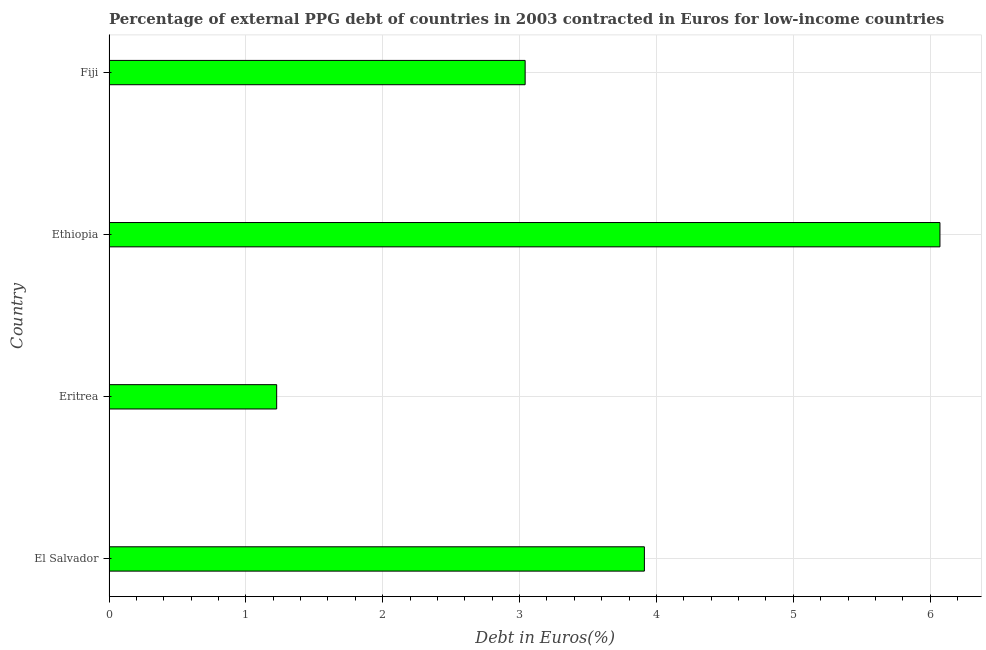Does the graph contain grids?
Your answer should be compact. Yes. What is the title of the graph?
Give a very brief answer. Percentage of external PPG debt of countries in 2003 contracted in Euros for low-income countries. What is the label or title of the X-axis?
Give a very brief answer. Debt in Euros(%). What is the label or title of the Y-axis?
Make the answer very short. Country. What is the currency composition of ppg debt in Fiji?
Offer a very short reply. 3.04. Across all countries, what is the maximum currency composition of ppg debt?
Your answer should be very brief. 6.07. Across all countries, what is the minimum currency composition of ppg debt?
Your answer should be compact. 1.23. In which country was the currency composition of ppg debt maximum?
Your answer should be very brief. Ethiopia. In which country was the currency composition of ppg debt minimum?
Your answer should be very brief. Eritrea. What is the sum of the currency composition of ppg debt?
Ensure brevity in your answer.  14.25. What is the difference between the currency composition of ppg debt in Ethiopia and Fiji?
Your answer should be very brief. 3.03. What is the average currency composition of ppg debt per country?
Offer a very short reply. 3.56. What is the median currency composition of ppg debt?
Provide a short and direct response. 3.48. In how many countries, is the currency composition of ppg debt greater than 4.4 %?
Offer a very short reply. 1. What is the ratio of the currency composition of ppg debt in El Salvador to that in Ethiopia?
Provide a succinct answer. 0.64. Is the difference between the currency composition of ppg debt in El Salvador and Fiji greater than the difference between any two countries?
Provide a succinct answer. No. What is the difference between the highest and the second highest currency composition of ppg debt?
Provide a succinct answer. 2.16. What is the difference between the highest and the lowest currency composition of ppg debt?
Provide a short and direct response. 4.85. In how many countries, is the currency composition of ppg debt greater than the average currency composition of ppg debt taken over all countries?
Ensure brevity in your answer.  2. How many bars are there?
Provide a short and direct response. 4. Are all the bars in the graph horizontal?
Offer a terse response. Yes. What is the difference between two consecutive major ticks on the X-axis?
Your answer should be compact. 1. Are the values on the major ticks of X-axis written in scientific E-notation?
Your answer should be very brief. No. What is the Debt in Euros(%) in El Salvador?
Provide a succinct answer. 3.91. What is the Debt in Euros(%) in Eritrea?
Provide a succinct answer. 1.23. What is the Debt in Euros(%) of Ethiopia?
Your answer should be compact. 6.07. What is the Debt in Euros(%) in Fiji?
Offer a terse response. 3.04. What is the difference between the Debt in Euros(%) in El Salvador and Eritrea?
Keep it short and to the point. 2.69. What is the difference between the Debt in Euros(%) in El Salvador and Ethiopia?
Provide a succinct answer. -2.16. What is the difference between the Debt in Euros(%) in El Salvador and Fiji?
Provide a succinct answer. 0.87. What is the difference between the Debt in Euros(%) in Eritrea and Ethiopia?
Ensure brevity in your answer.  -4.85. What is the difference between the Debt in Euros(%) in Eritrea and Fiji?
Your answer should be compact. -1.82. What is the difference between the Debt in Euros(%) in Ethiopia and Fiji?
Make the answer very short. 3.03. What is the ratio of the Debt in Euros(%) in El Salvador to that in Eritrea?
Your answer should be compact. 3.19. What is the ratio of the Debt in Euros(%) in El Salvador to that in Ethiopia?
Your answer should be very brief. 0.64. What is the ratio of the Debt in Euros(%) in El Salvador to that in Fiji?
Your answer should be compact. 1.29. What is the ratio of the Debt in Euros(%) in Eritrea to that in Ethiopia?
Keep it short and to the point. 0.2. What is the ratio of the Debt in Euros(%) in Eritrea to that in Fiji?
Ensure brevity in your answer.  0.4. What is the ratio of the Debt in Euros(%) in Ethiopia to that in Fiji?
Offer a terse response. 2. 